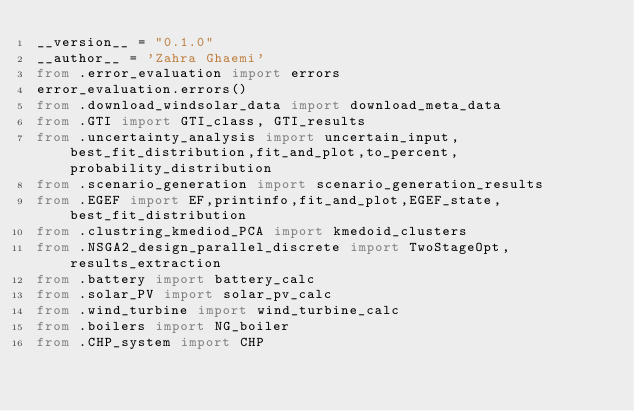Convert code to text. <code><loc_0><loc_0><loc_500><loc_500><_Python_>__version__ = "0.1.0"
__author__ = 'Zahra Ghaemi'
from .error_evaluation import errors
error_evaluation.errors()
from .download_windsolar_data import download_meta_data
from .GTI import GTI_class, GTI_results
from .uncertainty_analysis import uncertain_input,best_fit_distribution,fit_and_plot,to_percent,probability_distribution
from .scenario_generation import scenario_generation_results
from .EGEF import EF,printinfo,fit_and_plot,EGEF_state,best_fit_distribution
from .clustring_kmediod_PCA import kmedoid_clusters
from .NSGA2_design_parallel_discrete import TwoStageOpt,results_extraction
from .battery import battery_calc
from .solar_PV import solar_pv_calc
from .wind_turbine import wind_turbine_calc
from .boilers import NG_boiler
from .CHP_system import CHP
</code> 